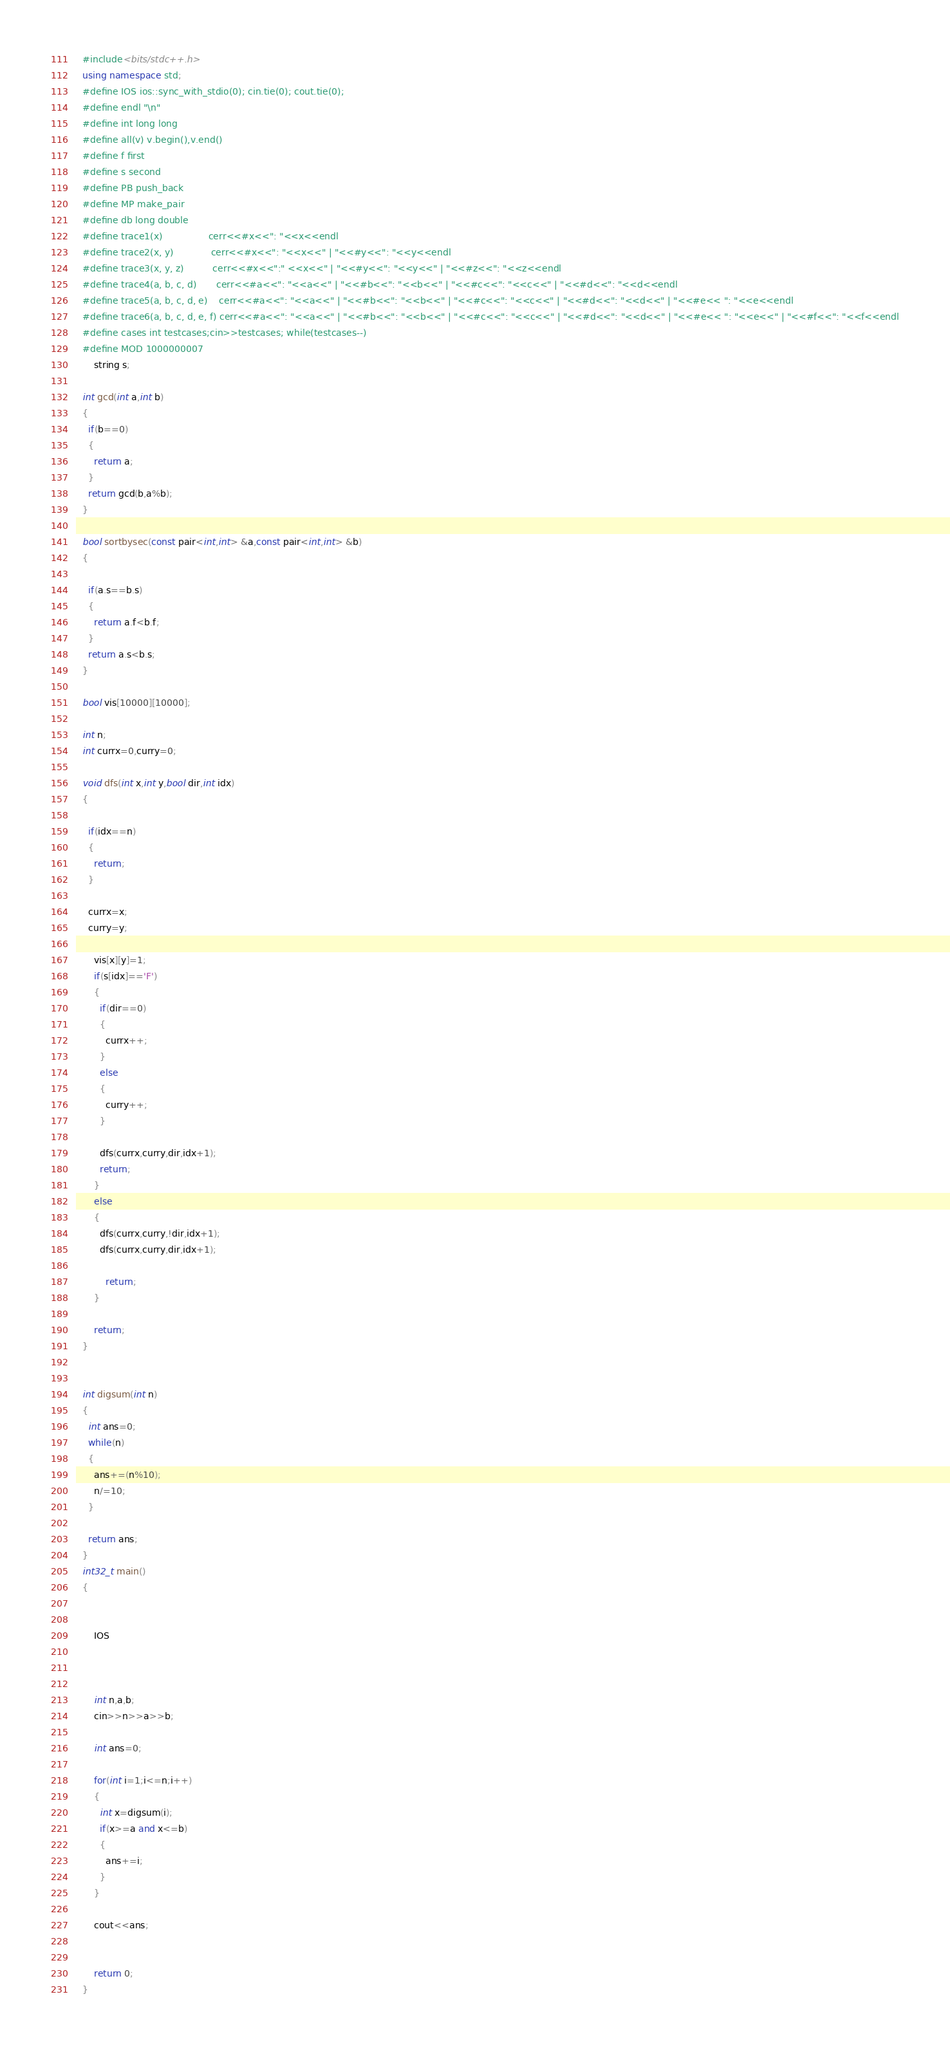<code> <loc_0><loc_0><loc_500><loc_500><_C++_>  #include<bits/stdc++.h>
  using namespace std;
  #define IOS ios::sync_with_stdio(0); cin.tie(0); cout.tie(0);
  #define endl "\n"
  #define int long long
  #define all(v) v.begin(),v.end()
  #define f first
  #define s second
  #define PB push_back
  #define MP make_pair
  #define db long double
  #define trace1(x)                cerr<<#x<<": "<<x<<endl
  #define trace2(x, y)             cerr<<#x<<": "<<x<<" | "<<#y<<": "<<y<<endl
  #define trace3(x, y, z)          cerr<<#x<<":" <<x<<" | "<<#y<<": "<<y<<" | "<<#z<<": "<<z<<endl
  #define trace4(a, b, c, d)       cerr<<#a<<": "<<a<<" | "<<#b<<": "<<b<<" | "<<#c<<": "<<c<<" | "<<#d<<": "<<d<<endl
  #define trace5(a, b, c, d, e)    cerr<<#a<<": "<<a<<" | "<<#b<<": "<<b<<" | "<<#c<<": "<<c<<" | "<<#d<<": "<<d<<" | "<<#e<< ": "<<e<<endl
  #define trace6(a, b, c, d, e, f) cerr<<#a<<": "<<a<<" | "<<#b<<": "<<b<<" | "<<#c<<": "<<c<<" | "<<#d<<": "<<d<<" | "<<#e<< ": "<<e<<" | "<<#f<<": "<<f<<endl
  #define cases int testcases;cin>>testcases; while(testcases--)
  #define MOD 1000000007
      string s;

  int gcd(int a,int b)
  {
    if(b==0)
    {
      return a;
    }
    return gcd(b,a%b);
  }

  bool sortbysec(const pair<int,int> &a,const pair<int,int> &b)
  {

    if(a.s==b.s)
    {
      return a.f<b.f;
    }
    return a.s<b.s;
  }

  bool vis[10000][10000];

  int n;
  int currx=0,curry=0;

  void dfs(int x,int y,bool dir,int idx)
  {

    if(idx==n)
    {
      return;
    }

    currx=x;
    curry=y;

      vis[x][y]=1;
      if(s[idx]=='F')
      {
        if(dir==0)
        {
          currx++;
        }
        else
        {
          curry++;
        }

        dfs(currx,curry,dir,idx+1);
        return;
      }
      else
      {
        dfs(currx,curry,!dir,idx+1);
        dfs(currx,curry,dir,idx+1);
        
          return;
      } 

      return;
  }


  int digsum(int n)
  {
    int ans=0;
    while(n)
    {
      ans+=(n%10);
      n/=10;
    }

    return ans;
  }
  int32_t main()
  {         
    

      IOS

        
        
      int n,a,b;
      cin>>n>>a>>b;
      
      int ans=0;

      for(int i=1;i<=n;i++)
      {
        int x=digsum(i);
        if(x>=a and x<=b)
        {
          ans+=i;
        }
      }

      cout<<ans;


      return 0;
  }           </code> 